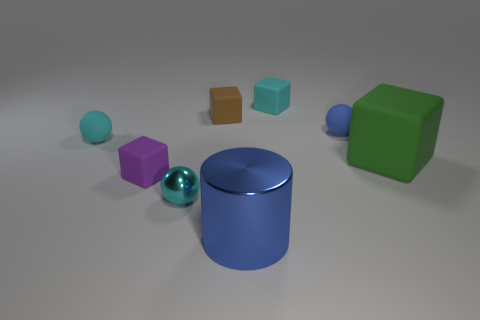Subtract all small matte spheres. How many spheres are left? 1 Add 1 blue metallic things. How many objects exist? 9 Subtract all purple cylinders. How many cyan spheres are left? 2 Subtract all cyan spheres. How many spheres are left? 1 Add 5 brown things. How many brown things are left? 6 Add 1 large cyan matte things. How many large cyan matte things exist? 1 Subtract 1 purple blocks. How many objects are left? 7 Subtract all spheres. How many objects are left? 5 Subtract 1 spheres. How many spheres are left? 2 Subtract all purple balls. Subtract all yellow cylinders. How many balls are left? 3 